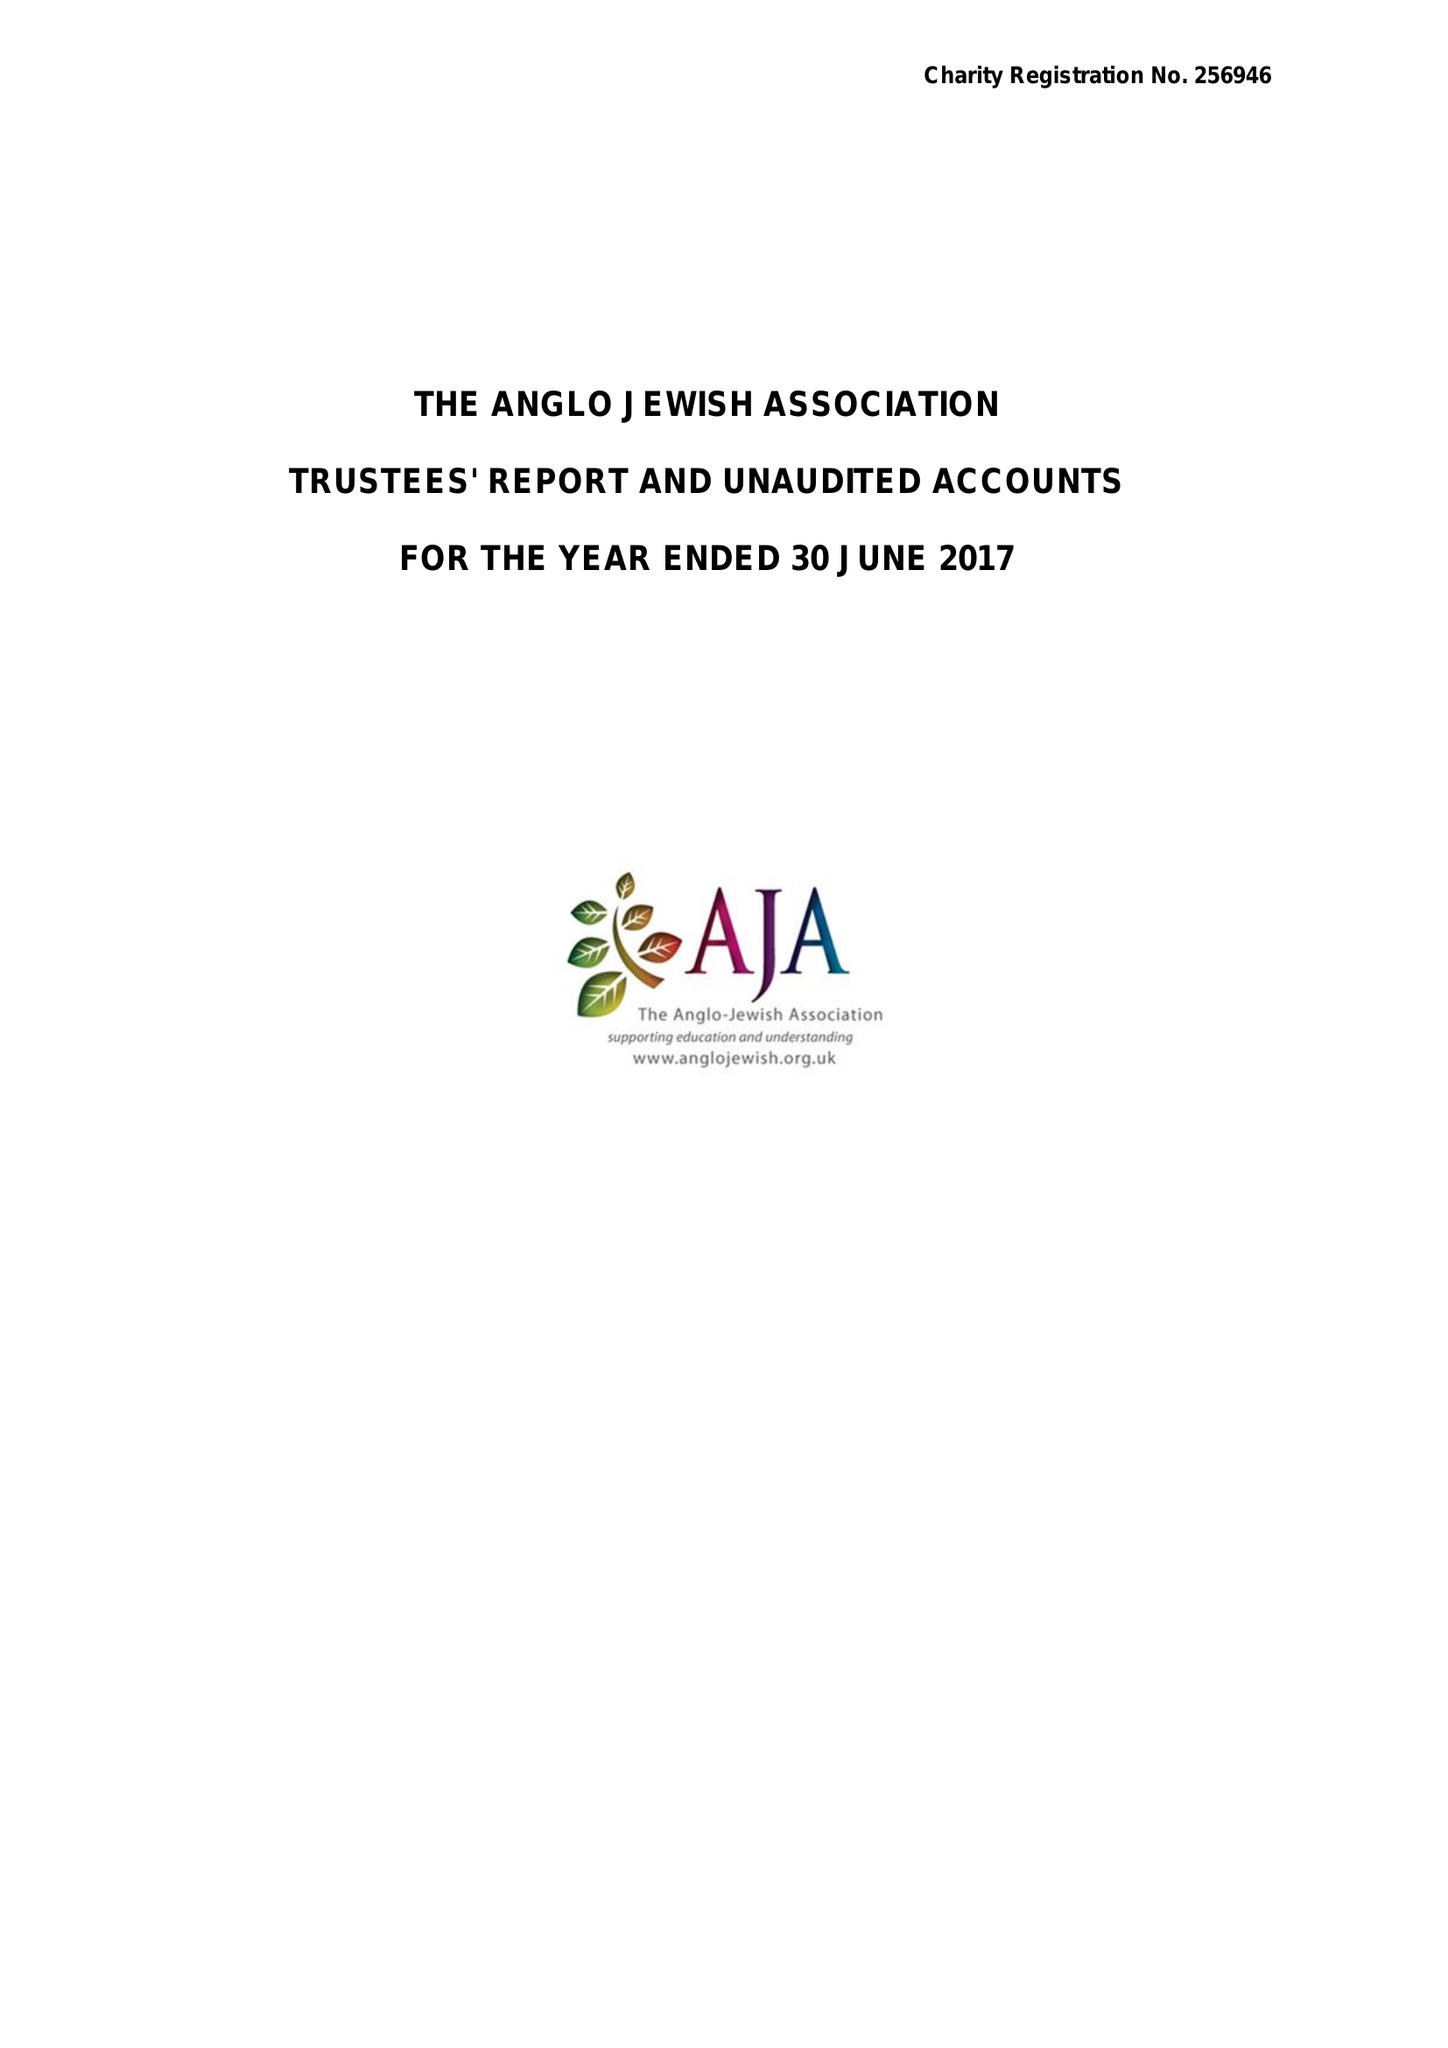What is the value for the address__post_town?
Answer the question using a single word or phrase. LONDON 